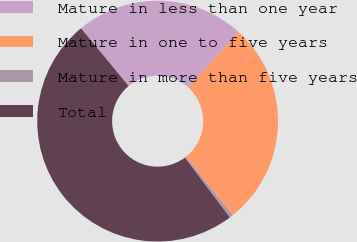Convert chart. <chart><loc_0><loc_0><loc_500><loc_500><pie_chart><fcel>Mature in less than one year<fcel>Mature in one to five years<fcel>Mature in more than five years<fcel>Total<nl><fcel>22.7%<fcel>27.58%<fcel>0.47%<fcel>49.26%<nl></chart> 